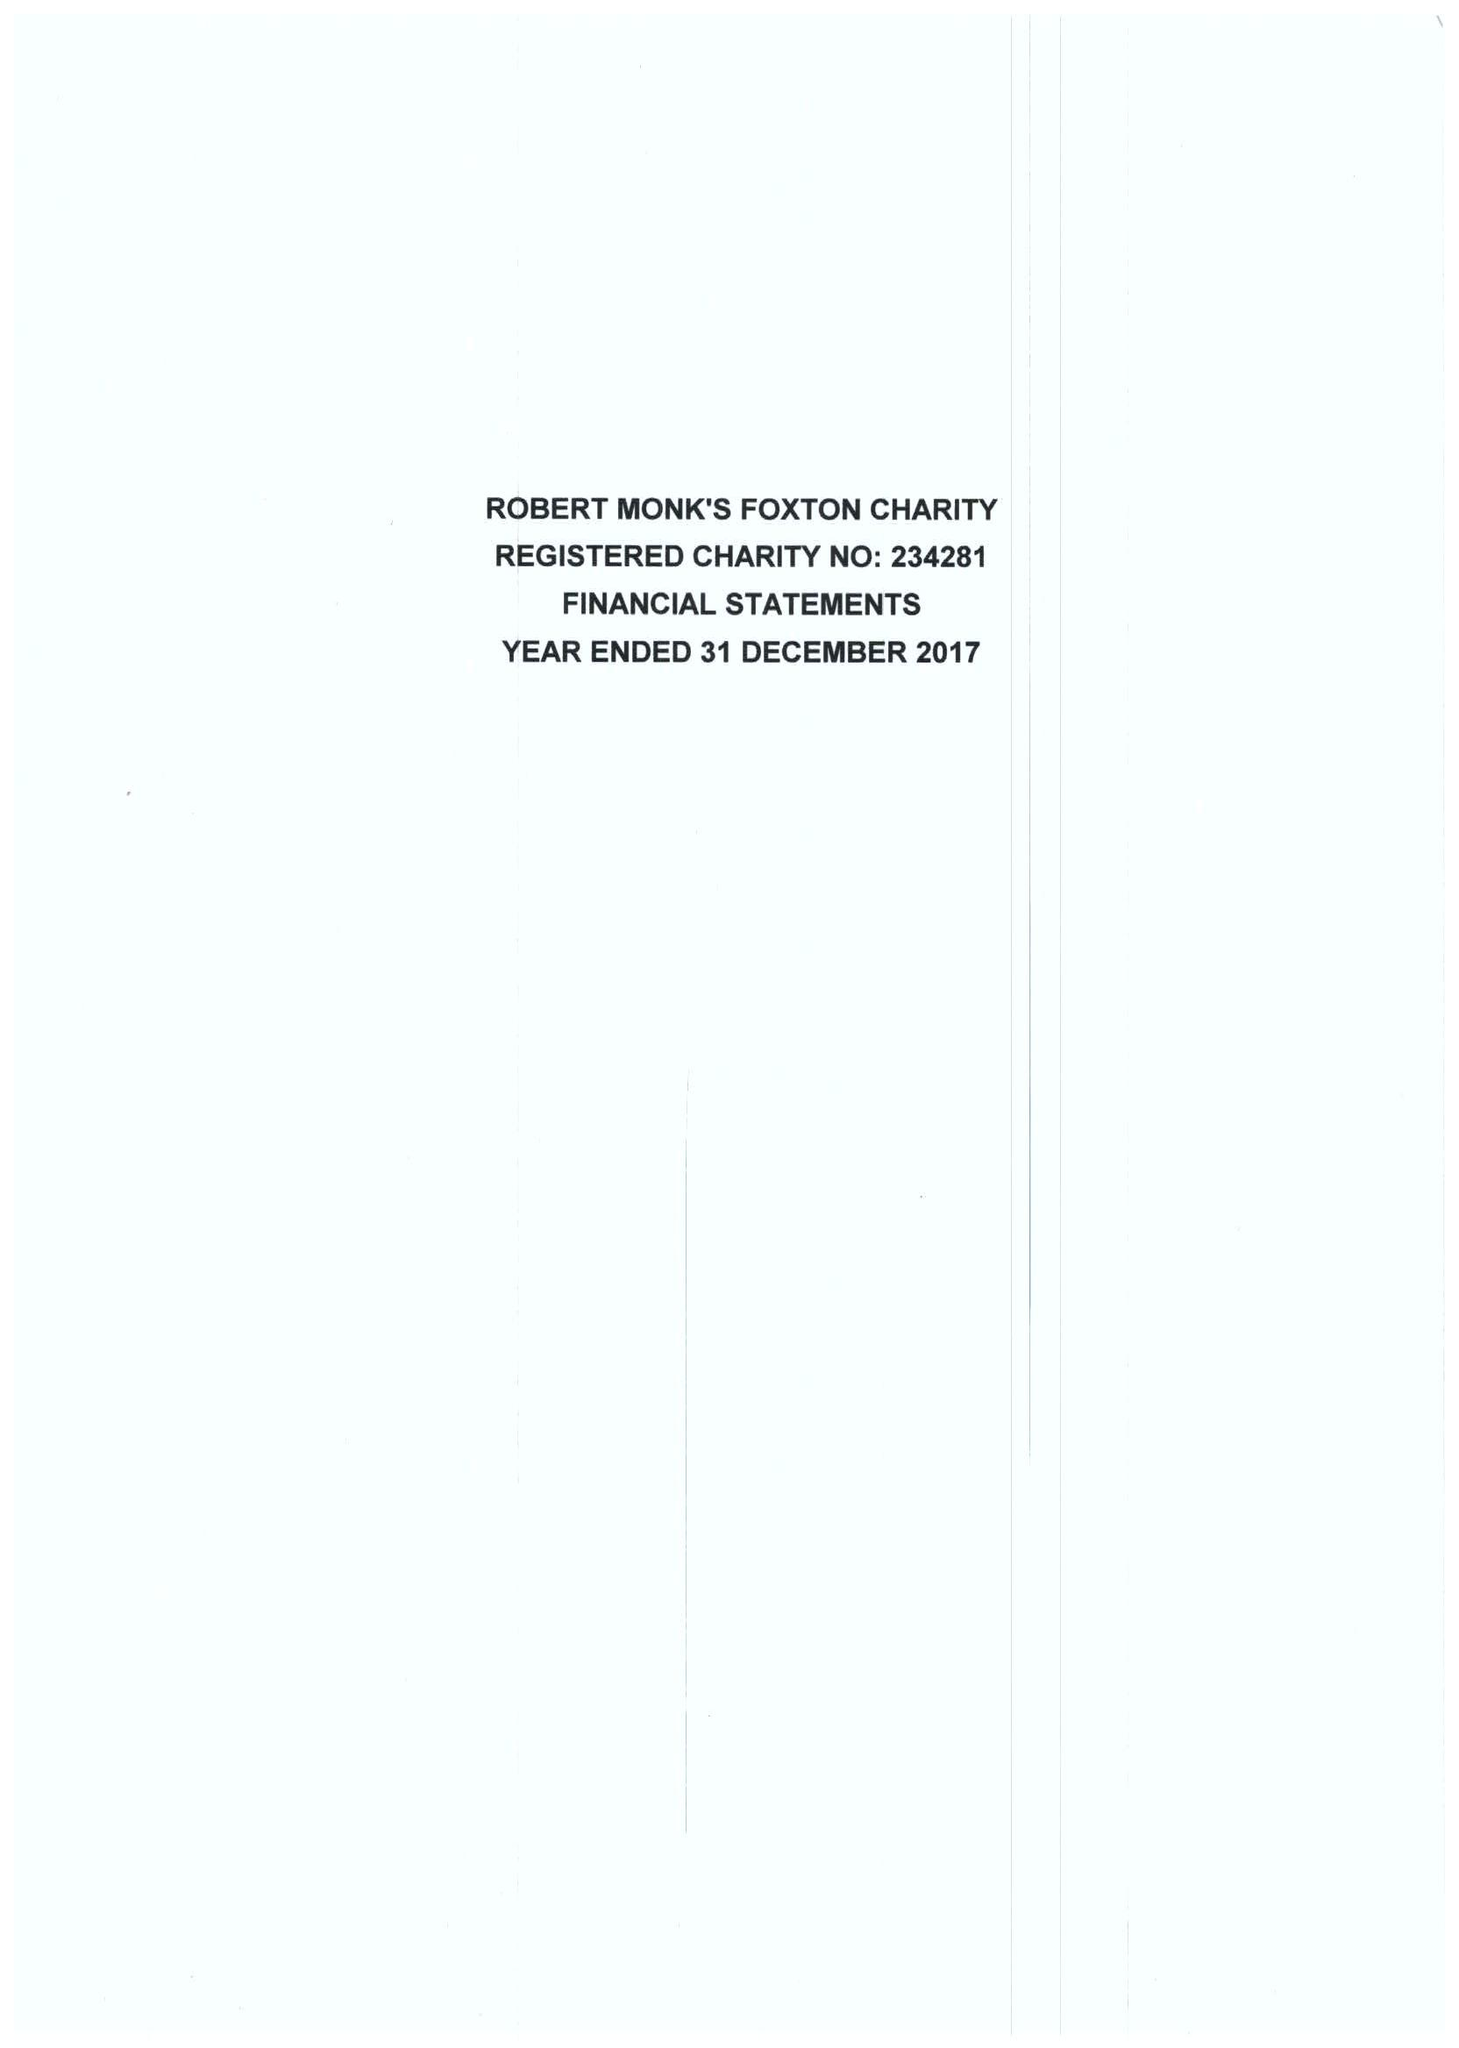What is the value for the charity_number?
Answer the question using a single word or phrase. 234281 